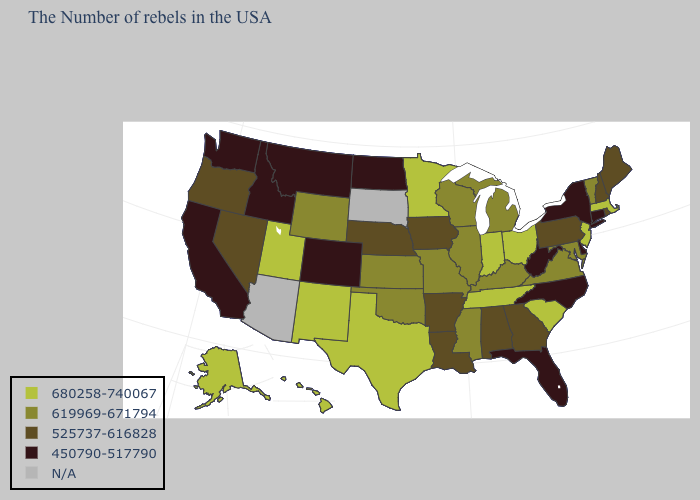Name the states that have a value in the range N/A?
Write a very short answer. South Dakota, Arizona. Name the states that have a value in the range N/A?
Give a very brief answer. South Dakota, Arizona. Which states have the lowest value in the USA?
Short answer required. Connecticut, New York, Delaware, North Carolina, West Virginia, Florida, North Dakota, Colorado, Montana, Idaho, California, Washington. What is the value of Kentucky?
Concise answer only. 619969-671794. Does the map have missing data?
Write a very short answer. Yes. Does Delaware have the lowest value in the USA?
Answer briefly. Yes. Among the states that border Tennessee , which have the highest value?
Concise answer only. Virginia, Kentucky, Mississippi, Missouri. What is the value of Virginia?
Quick response, please. 619969-671794. Name the states that have a value in the range 680258-740067?
Short answer required. Massachusetts, New Jersey, South Carolina, Ohio, Indiana, Tennessee, Minnesota, Texas, New Mexico, Utah, Alaska, Hawaii. Name the states that have a value in the range N/A?
Give a very brief answer. South Dakota, Arizona. Does North Dakota have the lowest value in the MidWest?
Write a very short answer. Yes. Among the states that border Missouri , which have the highest value?
Be succinct. Tennessee. What is the lowest value in the USA?
Answer briefly. 450790-517790. Name the states that have a value in the range 619969-671794?
Give a very brief answer. Vermont, Maryland, Virginia, Michigan, Kentucky, Wisconsin, Illinois, Mississippi, Missouri, Kansas, Oklahoma, Wyoming. Is the legend a continuous bar?
Quick response, please. No. 